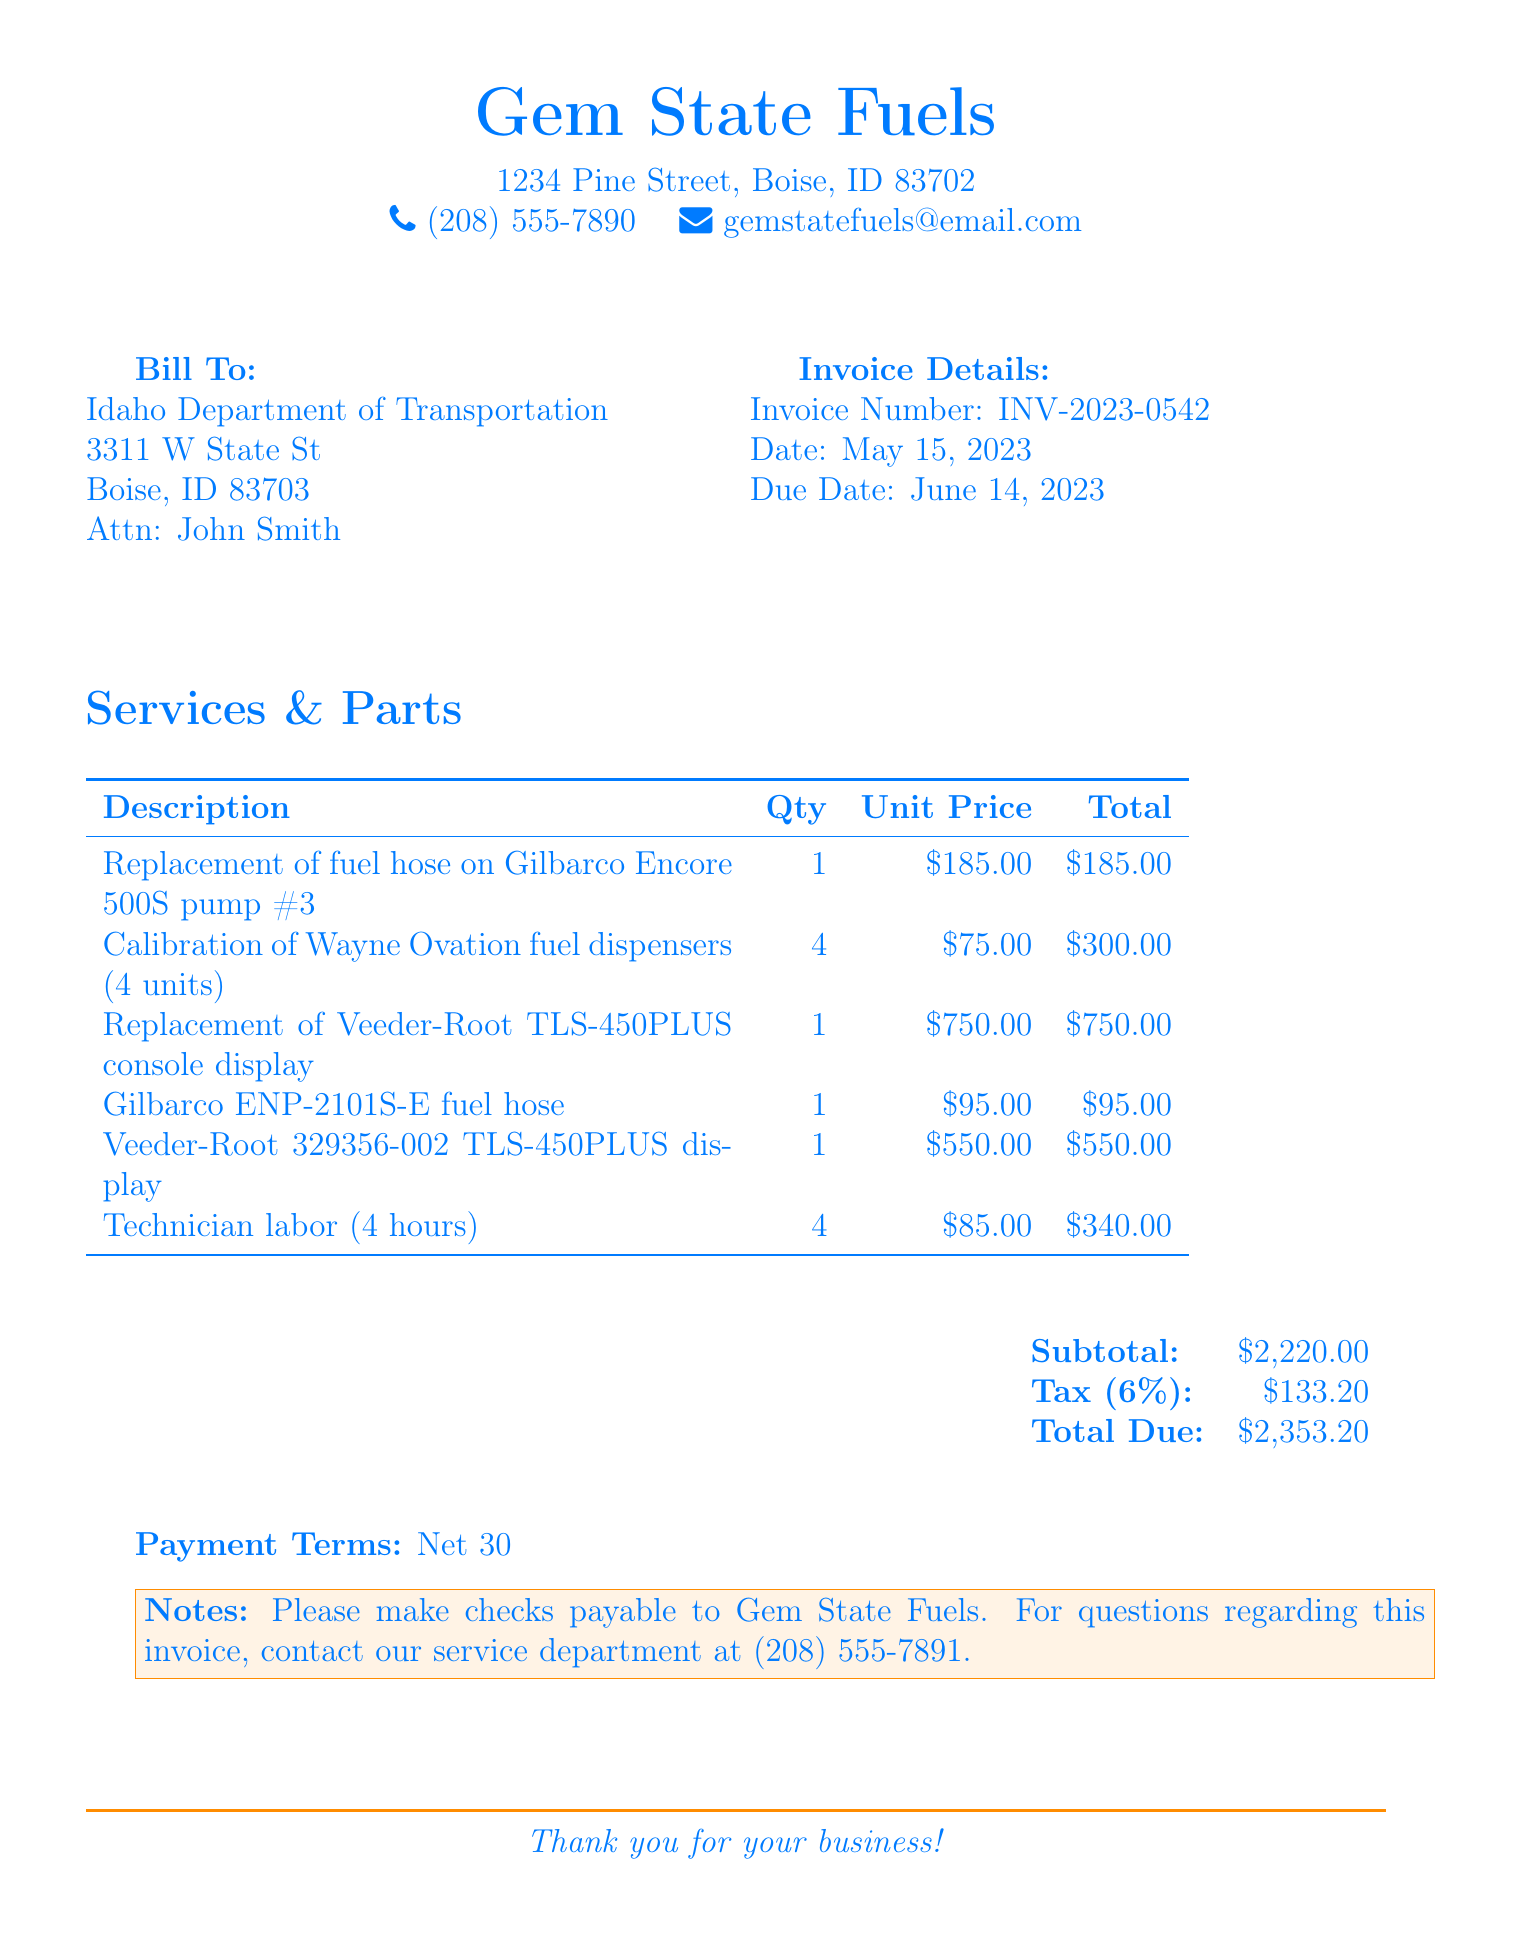what is the invoice number? The invoice number is a unique identifier for the bill provided in the document.
Answer: INV-2023-0542 what is the due date? The due date indicates when the payment for the invoice must be made.
Answer: June 14, 2023 how many hours of technician labor were billed? The document lists the hours of technician labor that were charged for the services provided.
Answer: 4 hours what is the subtotal amount? The subtotal amount is the total cost of the services and parts before tax is added.
Answer: $2,220.00 what is the tax rate applied? The tax rate shows the percentage of tax applied to the subtotal amount in the invoice.
Answer: 6% which company is billed? This identifies the organization that is responsible for paying the invoice.
Answer: Idaho Department of Transportation what is the total due? The total due indicates the complete amount that needs to be paid by the client, including tax.
Answer: $2,353.20 what service was performed on the Gilbarco Encore 500S pump? This question concerns a specific task mentioned in the invoice description section.
Answer: Replacement of fuel hose what payment terms are specified? Payment terms outline the agreed timeframe within which payment should be made by the client.
Answer: Net 30 who should checks be made payable to? This identifies the entity to which the payment checks should be issued as specified in the notes.
Answer: Gem State Fuels 